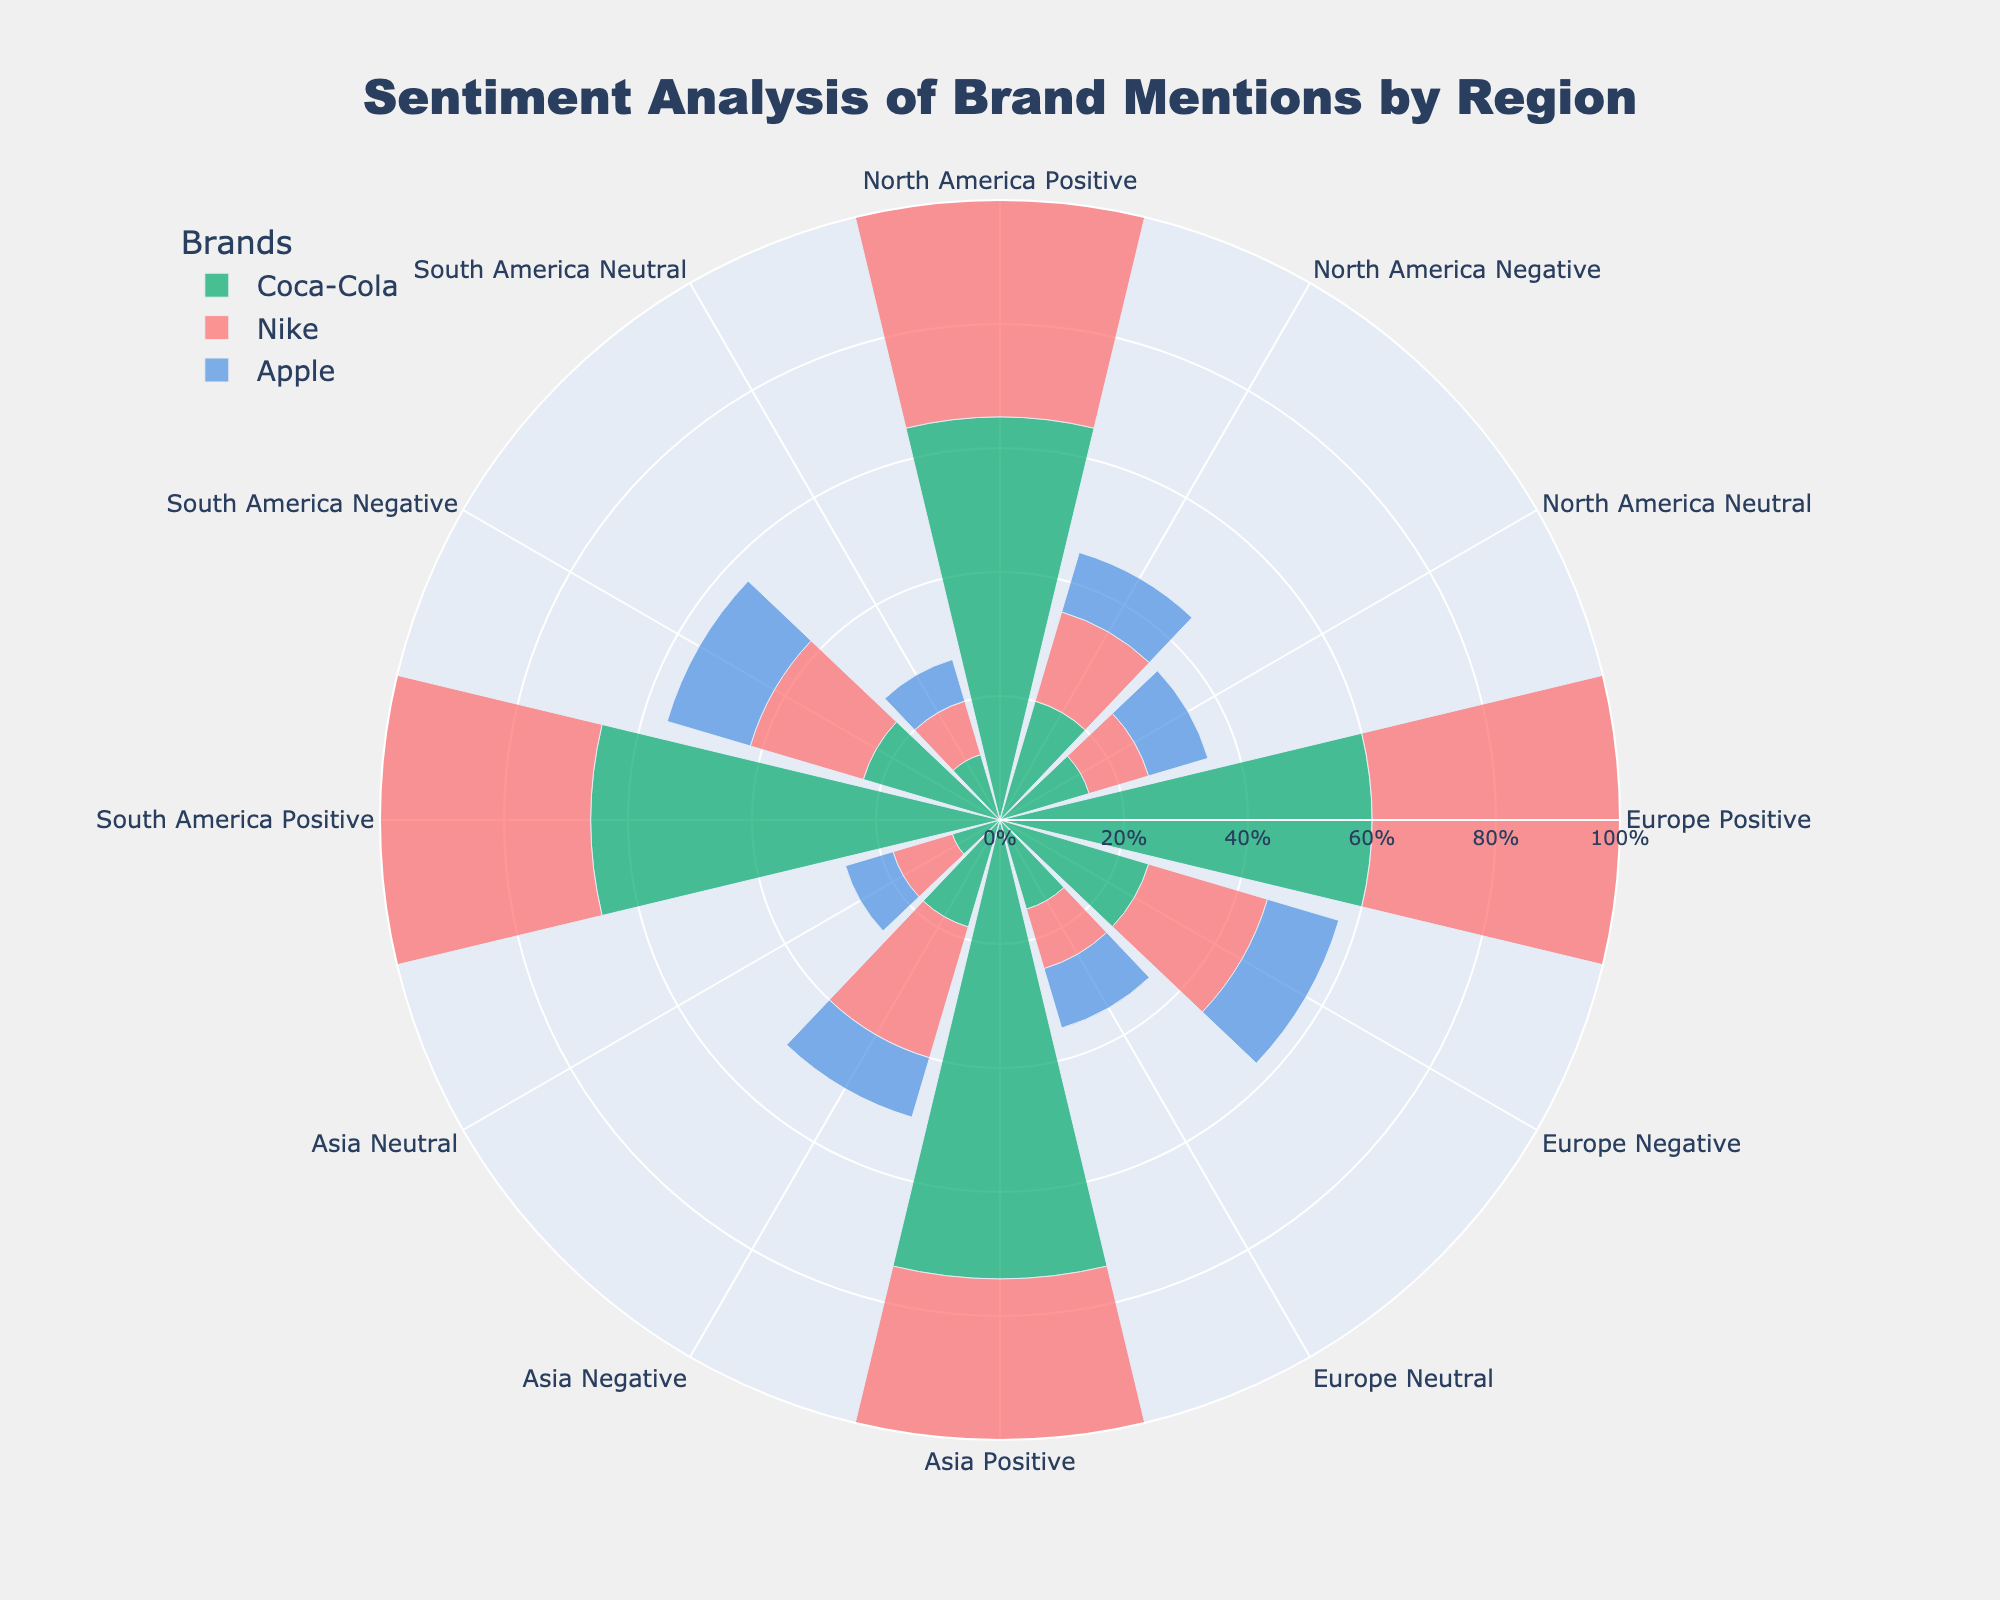What's the title of the figure? The title is usually prominently displayed at the top of the figure. Here, it reads "Sentiment Analysis of Brand Mentions by Region."
Answer: Sentiment Analysis of Brand Mentions by Region What are the three categories represented in each region? Each region's sentiments are divided into three categories: Positive Percentage, Negative Percentage, and Neutral Percentage. These are shown by different sections in the rose chart.
Answer: Positive Percentage, Negative Percentage, Neutral Percentage Which brand has the highest positive percentage in Asia? You can identify this by looking at the sections marked with "Asia Positive" and finding the one with the longest bar. Apple has the longest bar in this category.
Answer: Apple Compare the negative sentiment of Coca-Cola between North America and Europe. Which region has a higher percentage? Find the bars labeled "North America Negative" and "Europe Negative" for Coca-Cola. Europe has a higher bar at 25% compared to North America's 20%.
Answer: Europe What is the average positive percentage of Nike across all regions? Sum the positive percentages for Nike in all regions (75% + 70% + 68% + 72%) and then divide by the number of regions, which is 4. The average is (75 + 70 + 68 + 72) / 4 = 71.25%.
Answer: 71.25% Which region has the smallest neutral percentage for Apple? Locate the bars labeled "Neutral" for Apple in each region. The smallest neutral percentage for Apple is in Asia at 8%.
Answer: Asia How does Coca-Cola's negative sentiment in South America compare to that in Asia? Compare "South America Negative" and "Asia Negative" for Coca-Cola. South America has 23% negative sentiment, and Asia has 18%. Therefore, South America has a higher negative sentiment.
Answer: South America What is the difference in neutral sentiment for Apple between Europe and South America? Subtract the neutral percentage of Apple in South America from that in Europe. For Europe, it's 10%, and for South America, it's 7%. The difference is 10% - 7% = 3%.
Answer: 3% What brand has the highest overall positive sentiment in any region? Observe the "Positive" segments for all brands across all regions. Apple in Asia has the highest positive sentiment at 82%.
Answer: Apple in Asia Which region shows the most balanced sentiment distribution (i.e., percentages are close to each other) for Coca-Cola? Compare the sentiment percentages for Coca-Cola across regions and look for the closest values. Europe has the distribution 60% positive, 25% negative, and 15% neutral, which are relatively closest to each other compared to other regions.
Answer: Europe 